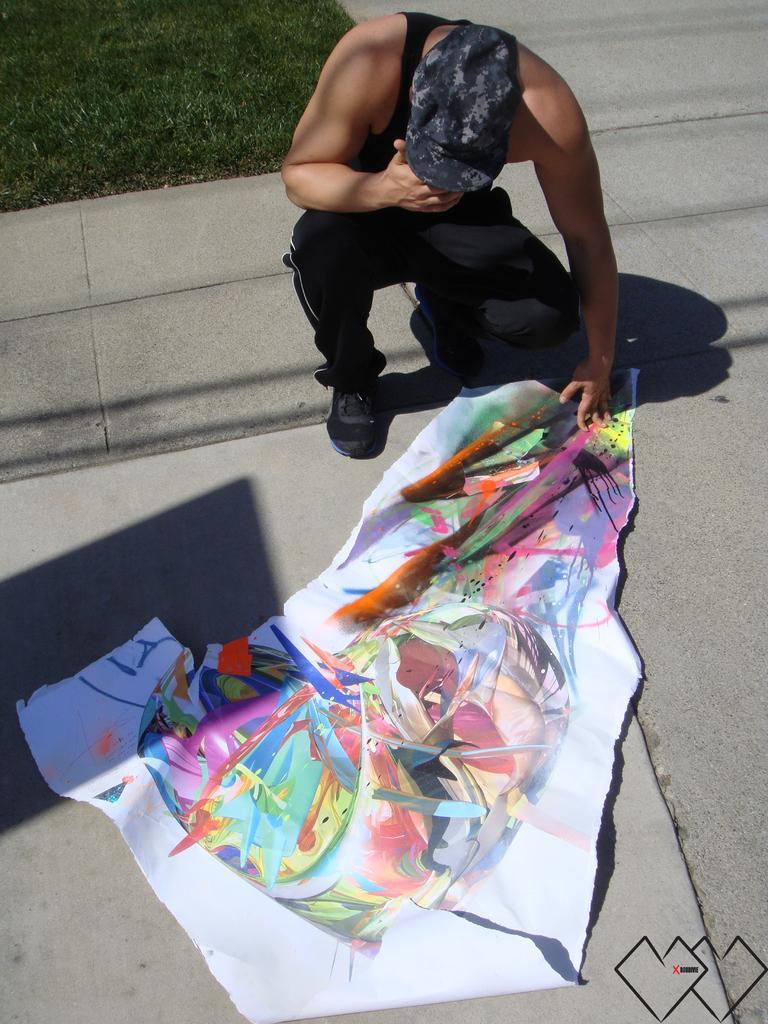Describe this image in one or two sentences. Here I can see a painting on a chart which is placed on the ground. Beside the chat there is a person wearing black color dress, cap on the head, sitting on the knees and looking at the downwards. In the top left there's grass on the ground. 